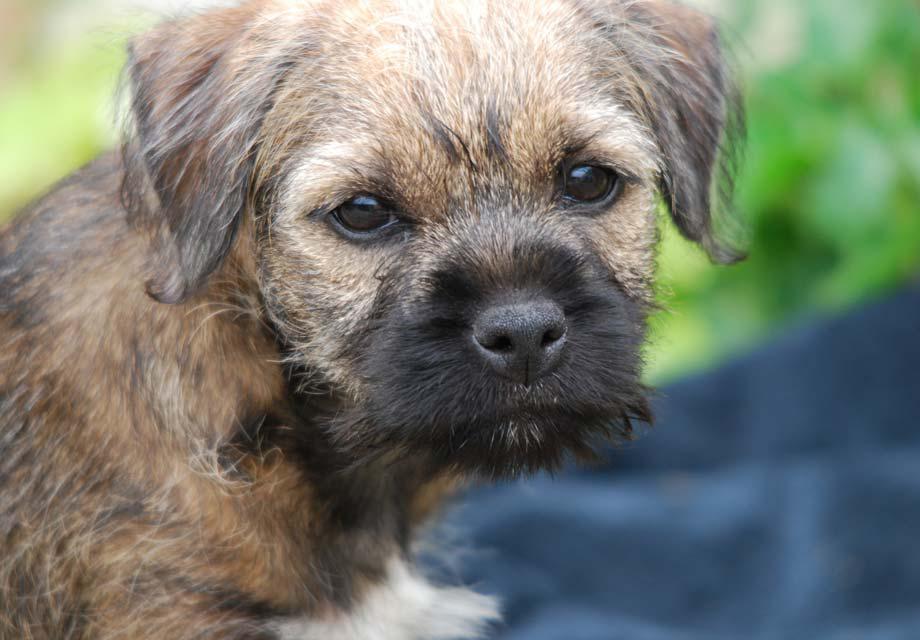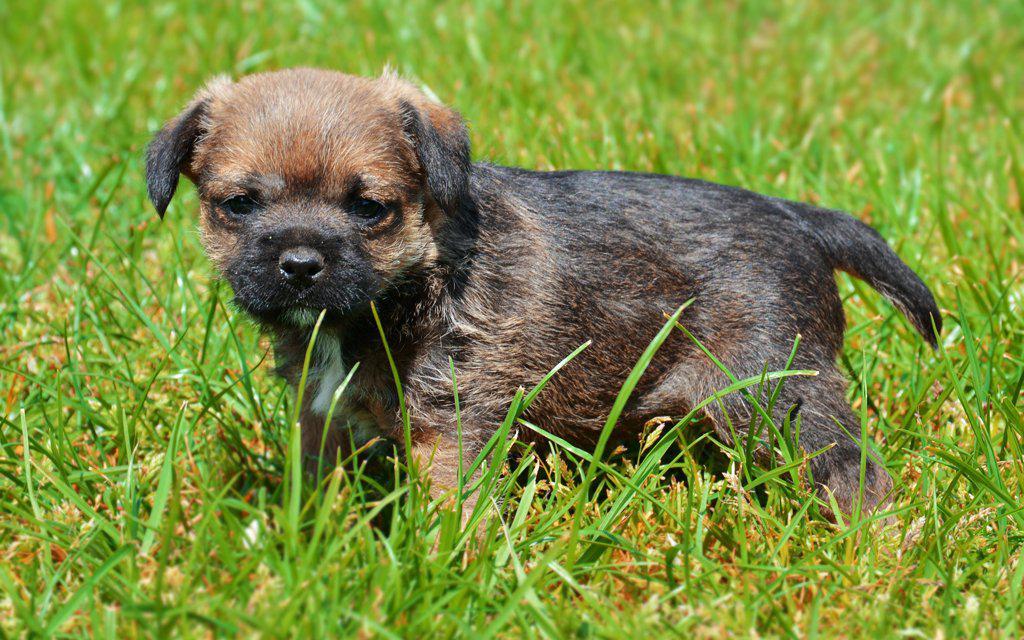The first image is the image on the left, the second image is the image on the right. Assess this claim about the two images: "All of the images contain only one dog.". Correct or not? Answer yes or no. Yes. The first image is the image on the left, the second image is the image on the right. Examine the images to the left and right. Is the description "There are two dogs" accurate? Answer yes or no. Yes. 